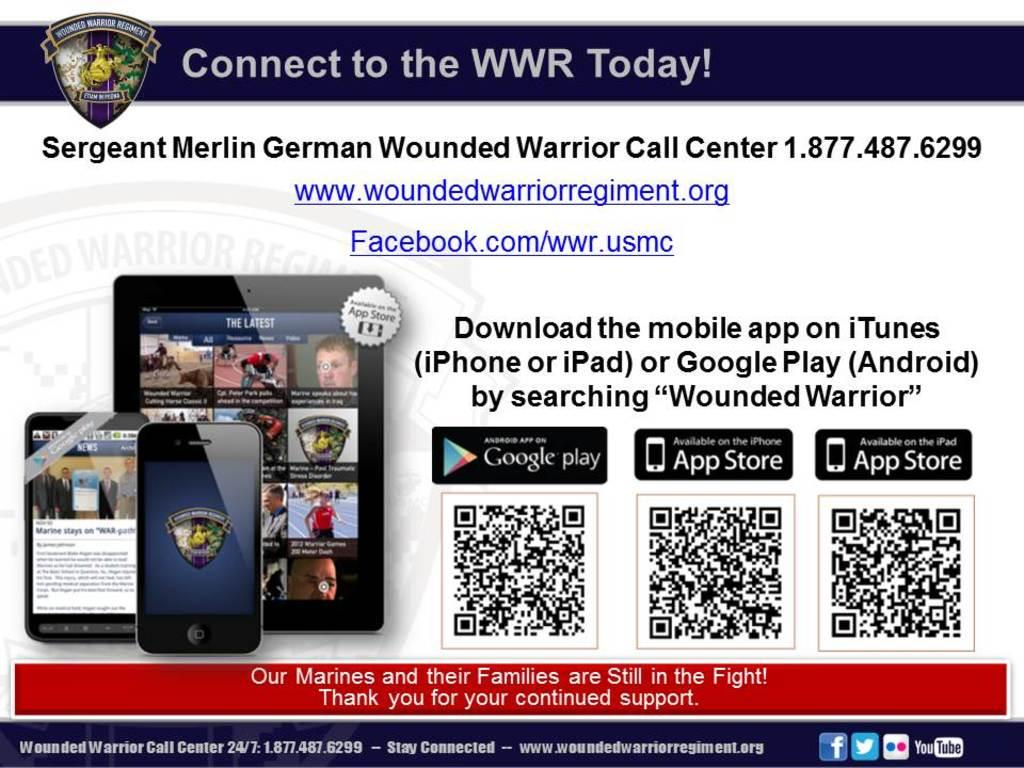<image>
Share a concise interpretation of the image provided. screen showing  mobile devices and various ways to connect to wounded warrior regiment 